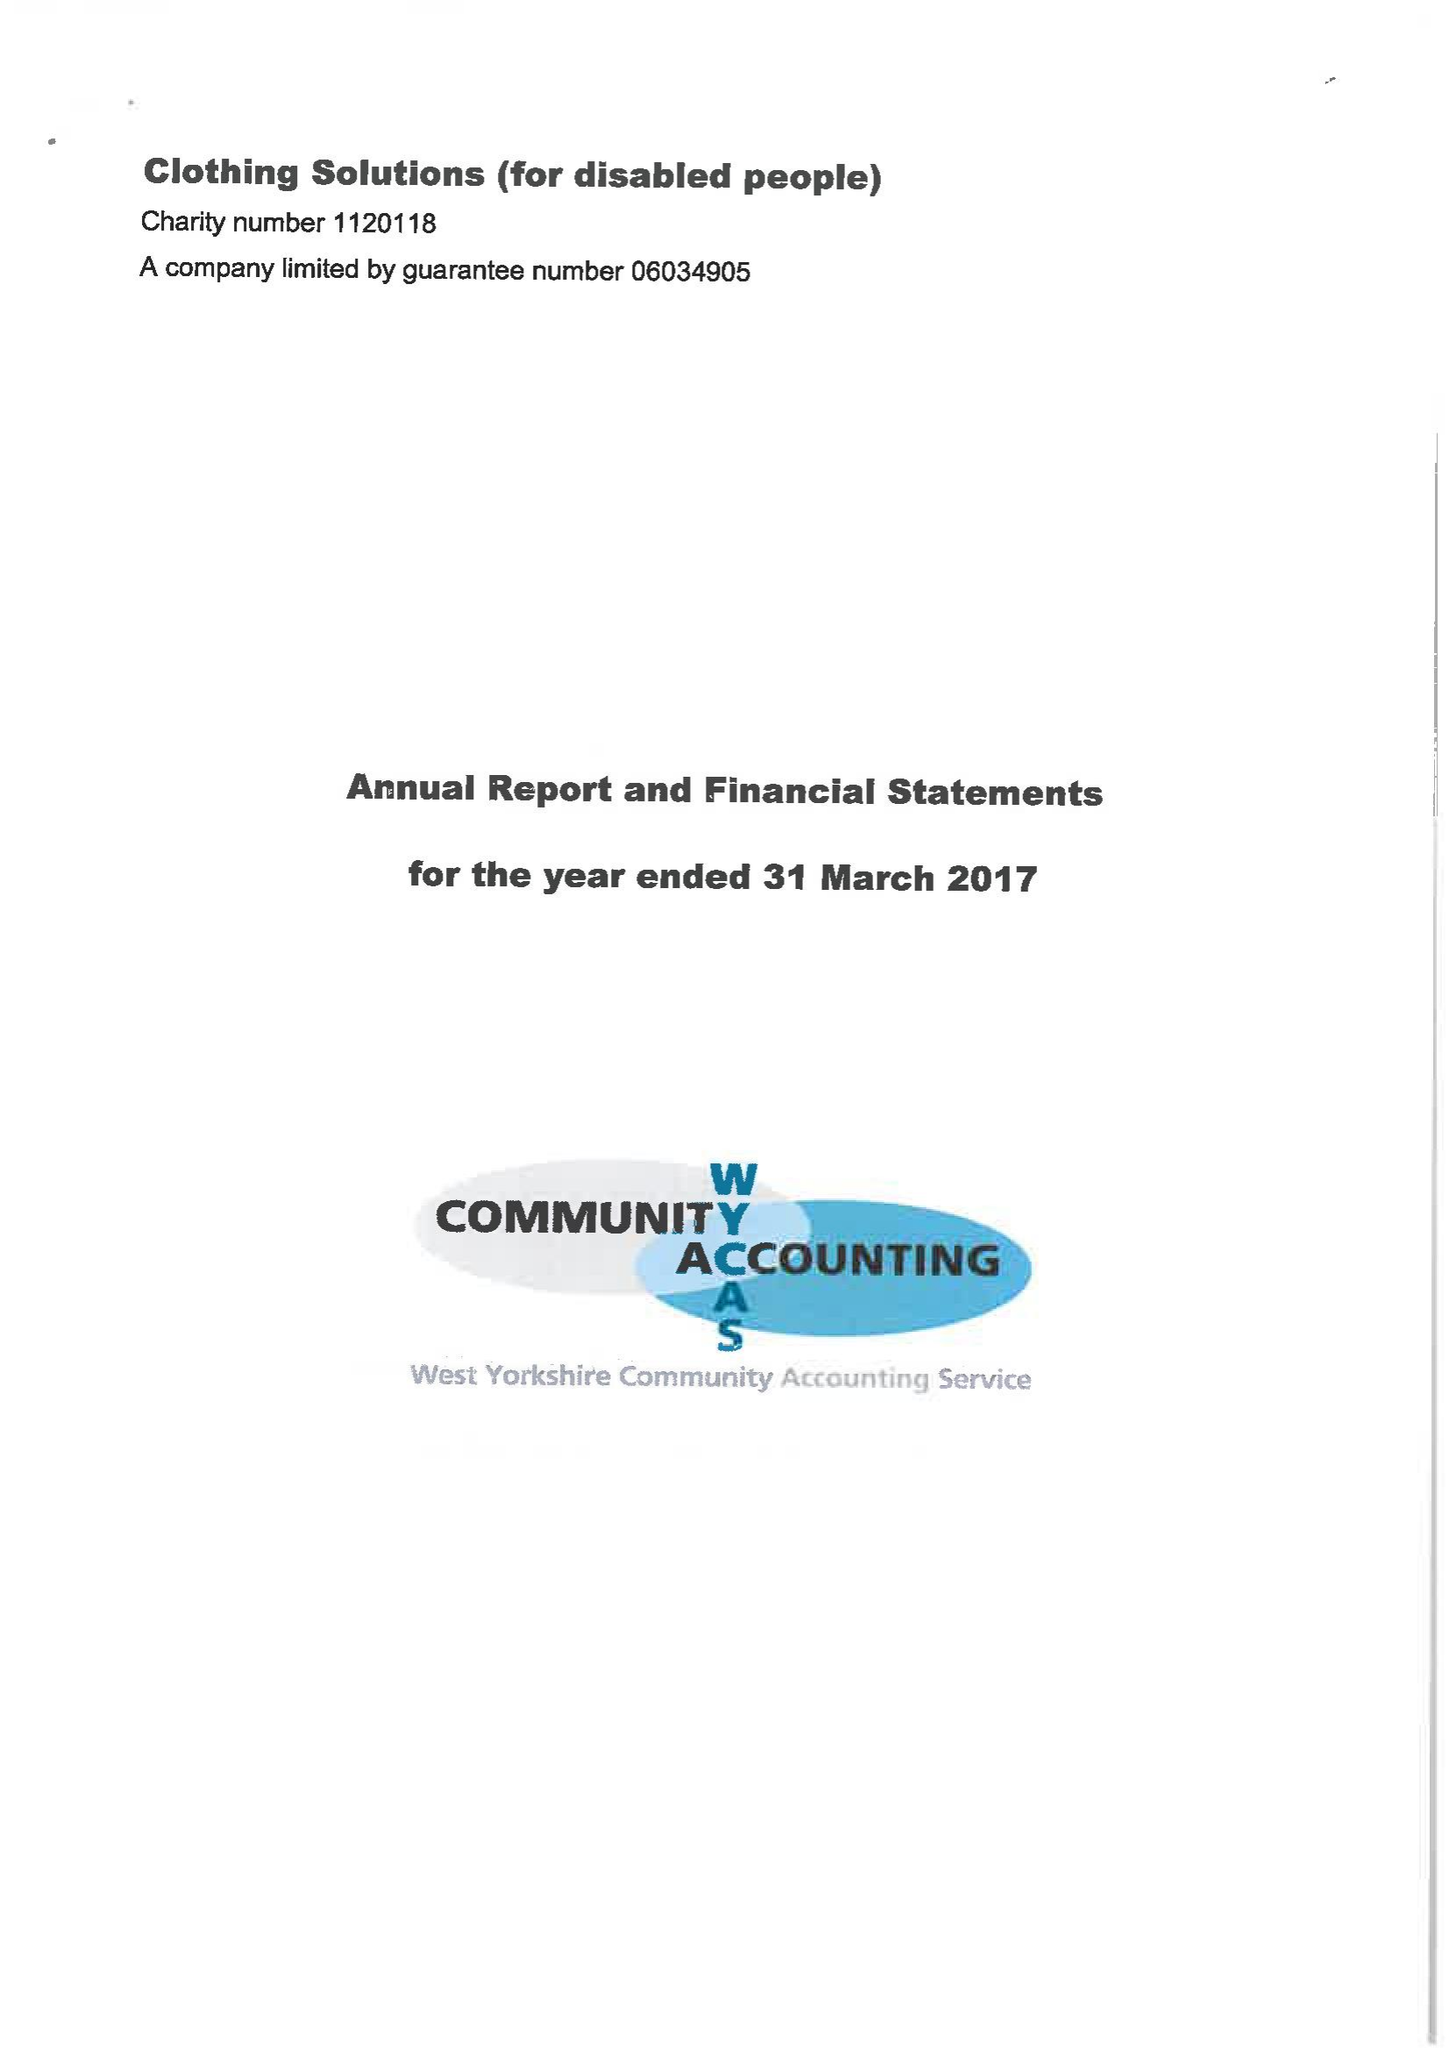What is the value for the income_annually_in_british_pounds?
Answer the question using a single word or phrase. 97746.00 